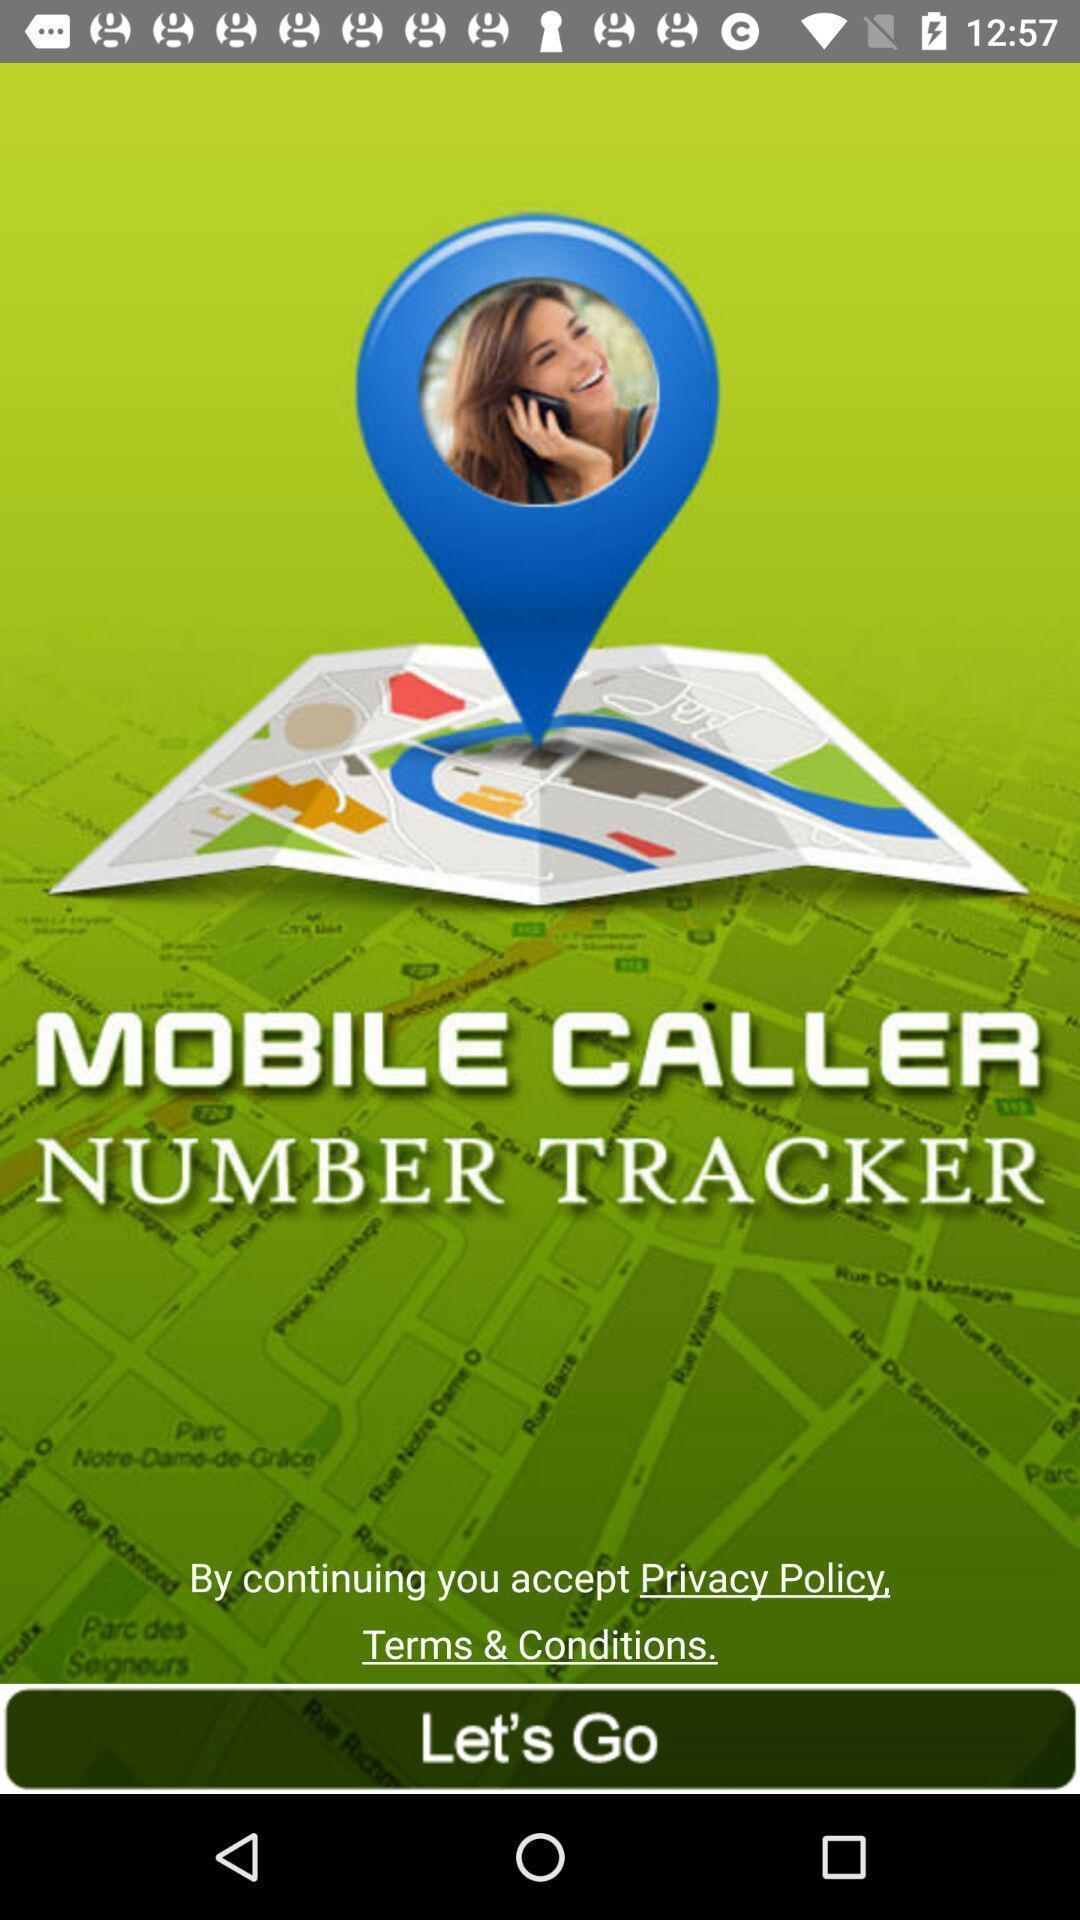Provide a description of this screenshot. Welcome page with let 's go option. 